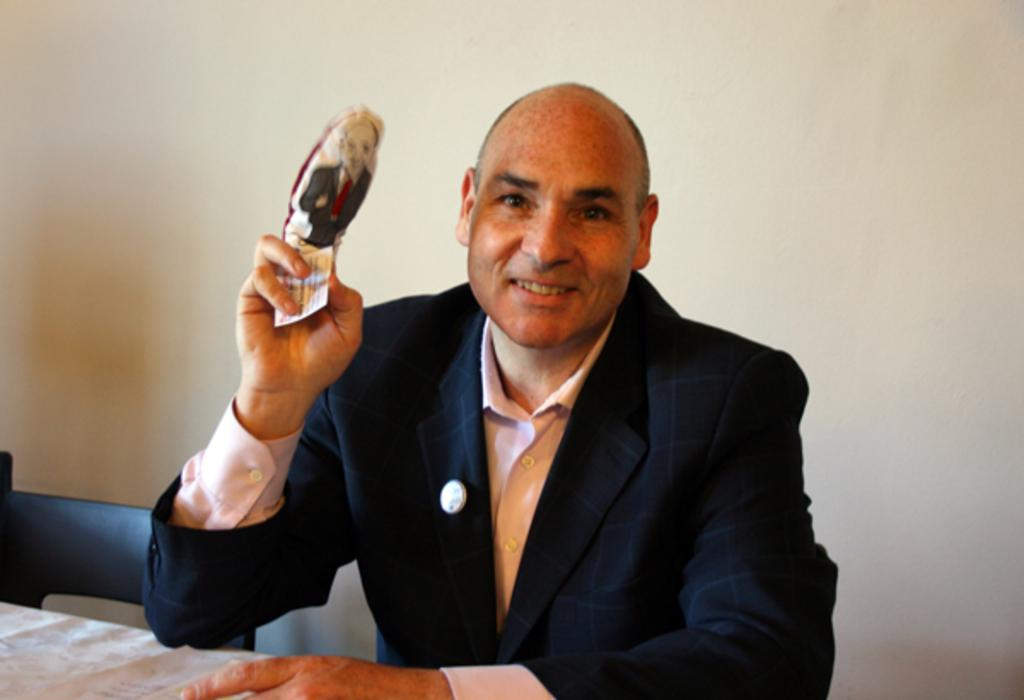What is the person in the image doing? The person is sitting on a chair in the image. What is the person holding in the image? The person is holding an object in the image. What piece of furniture is present in the image? There is a table in the image. What is visible in the background of the image? There is a wall in the image. How does the person plan to take a flight while sitting on the chair in the image? There is no indication in the image that the person is planning to take a flight or that a flight is even relevant to the scene. 